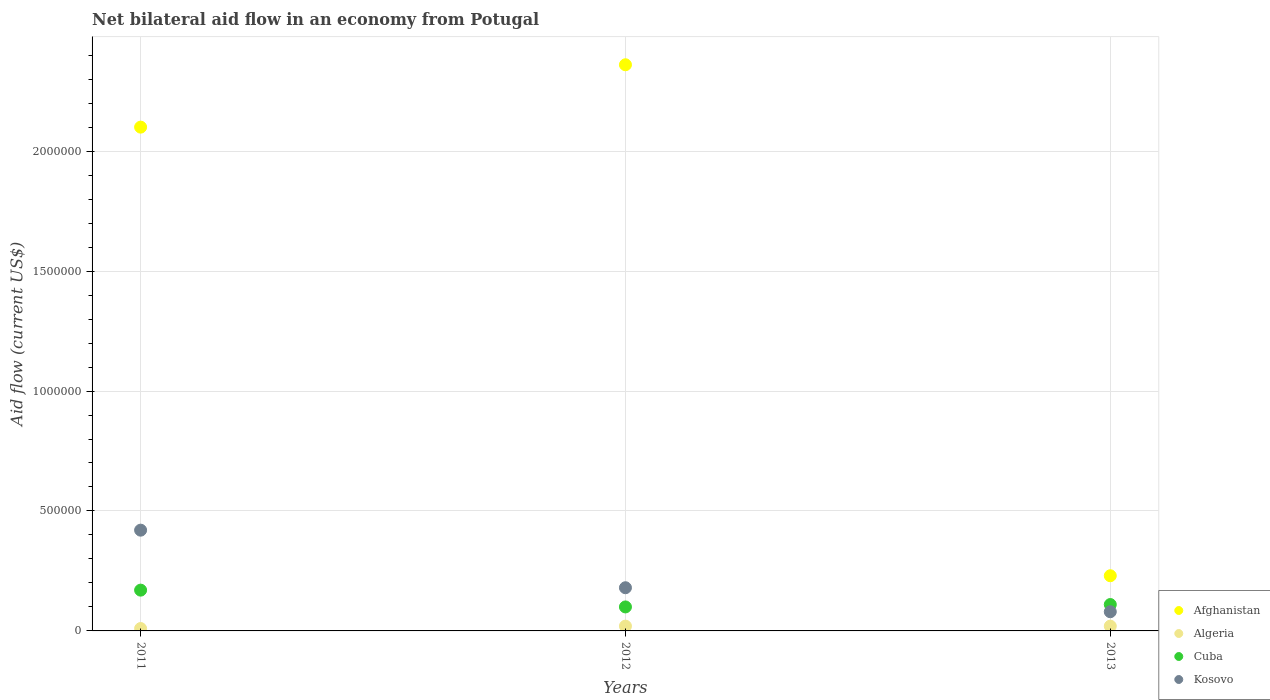How many different coloured dotlines are there?
Your response must be concise. 4. Is the number of dotlines equal to the number of legend labels?
Provide a short and direct response. Yes. Across all years, what is the maximum net bilateral aid flow in Algeria?
Give a very brief answer. 2.00e+04. Across all years, what is the minimum net bilateral aid flow in Cuba?
Make the answer very short. 1.00e+05. In which year was the net bilateral aid flow in Cuba maximum?
Your answer should be compact. 2011. In which year was the net bilateral aid flow in Afghanistan minimum?
Provide a short and direct response. 2013. What is the total net bilateral aid flow in Algeria in the graph?
Your response must be concise. 5.00e+04. What is the difference between the net bilateral aid flow in Afghanistan in 2011 and that in 2013?
Your response must be concise. 1.87e+06. What is the difference between the net bilateral aid flow in Afghanistan in 2011 and the net bilateral aid flow in Algeria in 2012?
Keep it short and to the point. 2.08e+06. What is the average net bilateral aid flow in Afghanistan per year?
Your answer should be compact. 1.56e+06. In the year 2012, what is the difference between the net bilateral aid flow in Algeria and net bilateral aid flow in Afghanistan?
Offer a terse response. -2.34e+06. In how many years, is the net bilateral aid flow in Afghanistan greater than 1700000 US$?
Your answer should be compact. 2. What is the ratio of the net bilateral aid flow in Kosovo in 2011 to that in 2013?
Give a very brief answer. 5.25. What is the difference between the highest and the second highest net bilateral aid flow in Cuba?
Offer a terse response. 6.00e+04. What is the difference between the highest and the lowest net bilateral aid flow in Kosovo?
Your answer should be compact. 3.40e+05. In how many years, is the net bilateral aid flow in Kosovo greater than the average net bilateral aid flow in Kosovo taken over all years?
Ensure brevity in your answer.  1. Does the net bilateral aid flow in Afghanistan monotonically increase over the years?
Keep it short and to the point. No. Is the net bilateral aid flow in Kosovo strictly greater than the net bilateral aid flow in Afghanistan over the years?
Provide a succinct answer. No. How many dotlines are there?
Keep it short and to the point. 4. How many years are there in the graph?
Ensure brevity in your answer.  3. What is the difference between two consecutive major ticks on the Y-axis?
Give a very brief answer. 5.00e+05. Are the values on the major ticks of Y-axis written in scientific E-notation?
Offer a terse response. No. Does the graph contain any zero values?
Your answer should be very brief. No. Where does the legend appear in the graph?
Offer a very short reply. Bottom right. How many legend labels are there?
Ensure brevity in your answer.  4. What is the title of the graph?
Keep it short and to the point. Net bilateral aid flow in an economy from Potugal. Does "Turkmenistan" appear as one of the legend labels in the graph?
Give a very brief answer. No. What is the label or title of the X-axis?
Your answer should be very brief. Years. What is the Aid flow (current US$) in Afghanistan in 2011?
Your answer should be very brief. 2.10e+06. What is the Aid flow (current US$) of Algeria in 2011?
Provide a succinct answer. 10000. What is the Aid flow (current US$) of Afghanistan in 2012?
Your answer should be very brief. 2.36e+06. What is the Aid flow (current US$) in Afghanistan in 2013?
Your answer should be compact. 2.30e+05. What is the Aid flow (current US$) of Algeria in 2013?
Give a very brief answer. 2.00e+04. What is the Aid flow (current US$) in Cuba in 2013?
Your response must be concise. 1.10e+05. Across all years, what is the maximum Aid flow (current US$) of Afghanistan?
Your response must be concise. 2.36e+06. Across all years, what is the maximum Aid flow (current US$) in Algeria?
Keep it short and to the point. 2.00e+04. Across all years, what is the maximum Aid flow (current US$) in Cuba?
Your answer should be compact. 1.70e+05. Across all years, what is the maximum Aid flow (current US$) of Kosovo?
Provide a short and direct response. 4.20e+05. Across all years, what is the minimum Aid flow (current US$) of Afghanistan?
Ensure brevity in your answer.  2.30e+05. Across all years, what is the minimum Aid flow (current US$) of Cuba?
Ensure brevity in your answer.  1.00e+05. What is the total Aid flow (current US$) in Afghanistan in the graph?
Offer a terse response. 4.69e+06. What is the total Aid flow (current US$) of Algeria in the graph?
Offer a very short reply. 5.00e+04. What is the total Aid flow (current US$) in Kosovo in the graph?
Provide a succinct answer. 6.80e+05. What is the difference between the Aid flow (current US$) in Afghanistan in 2011 and that in 2012?
Keep it short and to the point. -2.60e+05. What is the difference between the Aid flow (current US$) in Afghanistan in 2011 and that in 2013?
Make the answer very short. 1.87e+06. What is the difference between the Aid flow (current US$) of Algeria in 2011 and that in 2013?
Offer a very short reply. -10000. What is the difference between the Aid flow (current US$) of Kosovo in 2011 and that in 2013?
Offer a very short reply. 3.40e+05. What is the difference between the Aid flow (current US$) of Afghanistan in 2012 and that in 2013?
Provide a short and direct response. 2.13e+06. What is the difference between the Aid flow (current US$) in Algeria in 2012 and that in 2013?
Ensure brevity in your answer.  0. What is the difference between the Aid flow (current US$) of Cuba in 2012 and that in 2013?
Ensure brevity in your answer.  -10000. What is the difference between the Aid flow (current US$) in Kosovo in 2012 and that in 2013?
Provide a succinct answer. 1.00e+05. What is the difference between the Aid flow (current US$) in Afghanistan in 2011 and the Aid flow (current US$) in Algeria in 2012?
Provide a succinct answer. 2.08e+06. What is the difference between the Aid flow (current US$) in Afghanistan in 2011 and the Aid flow (current US$) in Kosovo in 2012?
Offer a terse response. 1.92e+06. What is the difference between the Aid flow (current US$) of Algeria in 2011 and the Aid flow (current US$) of Cuba in 2012?
Provide a succinct answer. -9.00e+04. What is the difference between the Aid flow (current US$) in Afghanistan in 2011 and the Aid flow (current US$) in Algeria in 2013?
Give a very brief answer. 2.08e+06. What is the difference between the Aid flow (current US$) of Afghanistan in 2011 and the Aid flow (current US$) of Cuba in 2013?
Keep it short and to the point. 1.99e+06. What is the difference between the Aid flow (current US$) of Afghanistan in 2011 and the Aid flow (current US$) of Kosovo in 2013?
Make the answer very short. 2.02e+06. What is the difference between the Aid flow (current US$) of Cuba in 2011 and the Aid flow (current US$) of Kosovo in 2013?
Your answer should be compact. 9.00e+04. What is the difference between the Aid flow (current US$) of Afghanistan in 2012 and the Aid flow (current US$) of Algeria in 2013?
Give a very brief answer. 2.34e+06. What is the difference between the Aid flow (current US$) in Afghanistan in 2012 and the Aid flow (current US$) in Cuba in 2013?
Provide a short and direct response. 2.25e+06. What is the difference between the Aid flow (current US$) of Afghanistan in 2012 and the Aid flow (current US$) of Kosovo in 2013?
Ensure brevity in your answer.  2.28e+06. What is the difference between the Aid flow (current US$) of Algeria in 2012 and the Aid flow (current US$) of Cuba in 2013?
Ensure brevity in your answer.  -9.00e+04. What is the difference between the Aid flow (current US$) of Cuba in 2012 and the Aid flow (current US$) of Kosovo in 2013?
Your answer should be very brief. 2.00e+04. What is the average Aid flow (current US$) of Afghanistan per year?
Give a very brief answer. 1.56e+06. What is the average Aid flow (current US$) of Algeria per year?
Provide a short and direct response. 1.67e+04. What is the average Aid flow (current US$) in Cuba per year?
Your answer should be compact. 1.27e+05. What is the average Aid flow (current US$) of Kosovo per year?
Your response must be concise. 2.27e+05. In the year 2011, what is the difference between the Aid flow (current US$) in Afghanistan and Aid flow (current US$) in Algeria?
Your answer should be compact. 2.09e+06. In the year 2011, what is the difference between the Aid flow (current US$) in Afghanistan and Aid flow (current US$) in Cuba?
Your answer should be compact. 1.93e+06. In the year 2011, what is the difference between the Aid flow (current US$) of Afghanistan and Aid flow (current US$) of Kosovo?
Your answer should be compact. 1.68e+06. In the year 2011, what is the difference between the Aid flow (current US$) in Algeria and Aid flow (current US$) in Kosovo?
Ensure brevity in your answer.  -4.10e+05. In the year 2011, what is the difference between the Aid flow (current US$) in Cuba and Aid flow (current US$) in Kosovo?
Offer a very short reply. -2.50e+05. In the year 2012, what is the difference between the Aid flow (current US$) of Afghanistan and Aid flow (current US$) of Algeria?
Offer a terse response. 2.34e+06. In the year 2012, what is the difference between the Aid flow (current US$) of Afghanistan and Aid flow (current US$) of Cuba?
Keep it short and to the point. 2.26e+06. In the year 2012, what is the difference between the Aid flow (current US$) of Afghanistan and Aid flow (current US$) of Kosovo?
Provide a short and direct response. 2.18e+06. In the year 2013, what is the difference between the Aid flow (current US$) of Afghanistan and Aid flow (current US$) of Algeria?
Ensure brevity in your answer.  2.10e+05. In the year 2013, what is the difference between the Aid flow (current US$) in Algeria and Aid flow (current US$) in Kosovo?
Offer a terse response. -6.00e+04. What is the ratio of the Aid flow (current US$) in Afghanistan in 2011 to that in 2012?
Ensure brevity in your answer.  0.89. What is the ratio of the Aid flow (current US$) in Algeria in 2011 to that in 2012?
Ensure brevity in your answer.  0.5. What is the ratio of the Aid flow (current US$) in Kosovo in 2011 to that in 2012?
Offer a very short reply. 2.33. What is the ratio of the Aid flow (current US$) of Afghanistan in 2011 to that in 2013?
Your answer should be very brief. 9.13. What is the ratio of the Aid flow (current US$) in Cuba in 2011 to that in 2013?
Your answer should be compact. 1.55. What is the ratio of the Aid flow (current US$) in Kosovo in 2011 to that in 2013?
Your answer should be compact. 5.25. What is the ratio of the Aid flow (current US$) of Afghanistan in 2012 to that in 2013?
Make the answer very short. 10.26. What is the ratio of the Aid flow (current US$) in Kosovo in 2012 to that in 2013?
Ensure brevity in your answer.  2.25. What is the difference between the highest and the second highest Aid flow (current US$) in Afghanistan?
Give a very brief answer. 2.60e+05. What is the difference between the highest and the second highest Aid flow (current US$) in Algeria?
Keep it short and to the point. 0. What is the difference between the highest and the lowest Aid flow (current US$) of Afghanistan?
Provide a short and direct response. 2.13e+06. What is the difference between the highest and the lowest Aid flow (current US$) of Algeria?
Provide a succinct answer. 10000. What is the difference between the highest and the lowest Aid flow (current US$) in Cuba?
Provide a short and direct response. 7.00e+04. 